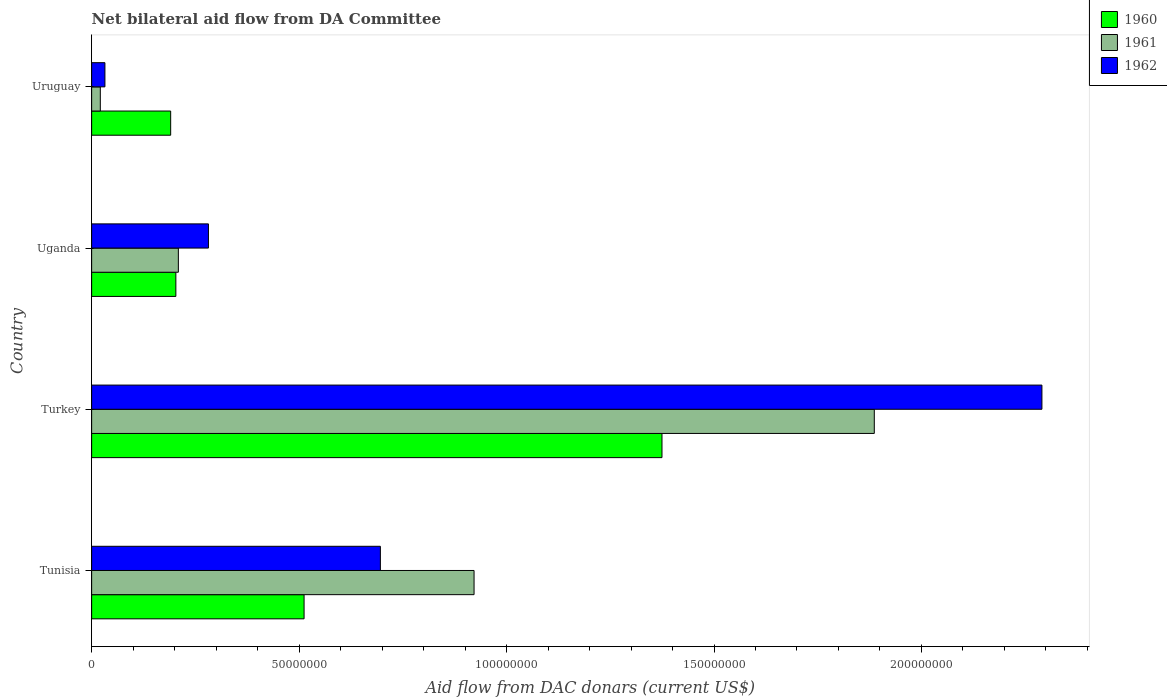How many different coloured bars are there?
Make the answer very short. 3. Are the number of bars per tick equal to the number of legend labels?
Your response must be concise. Yes. How many bars are there on the 1st tick from the top?
Keep it short and to the point. 3. How many bars are there on the 4th tick from the bottom?
Offer a terse response. 3. In how many cases, is the number of bars for a given country not equal to the number of legend labels?
Ensure brevity in your answer.  0. What is the aid flow in in 1960 in Turkey?
Keep it short and to the point. 1.37e+08. Across all countries, what is the maximum aid flow in in 1961?
Keep it short and to the point. 1.89e+08. Across all countries, what is the minimum aid flow in in 1962?
Provide a succinct answer. 3.20e+06. In which country was the aid flow in in 1962 minimum?
Provide a succinct answer. Uruguay. What is the total aid flow in in 1961 in the graph?
Provide a succinct answer. 3.04e+08. What is the difference between the aid flow in in 1960 in Tunisia and that in Uganda?
Keep it short and to the point. 3.09e+07. What is the difference between the aid flow in in 1962 in Tunisia and the aid flow in in 1960 in Uruguay?
Your answer should be very brief. 5.05e+07. What is the average aid flow in in 1962 per country?
Provide a short and direct response. 8.25e+07. What is the difference between the aid flow in in 1961 and aid flow in in 1962 in Turkey?
Make the answer very short. -4.04e+07. In how many countries, is the aid flow in in 1960 greater than 160000000 US$?
Give a very brief answer. 0. What is the ratio of the aid flow in in 1961 in Turkey to that in Uganda?
Make the answer very short. 9.03. Is the aid flow in in 1960 in Tunisia less than that in Uganda?
Your response must be concise. No. Is the difference between the aid flow in in 1961 in Uganda and Uruguay greater than the difference between the aid flow in in 1962 in Uganda and Uruguay?
Make the answer very short. No. What is the difference between the highest and the second highest aid flow in in 1960?
Offer a terse response. 8.63e+07. What is the difference between the highest and the lowest aid flow in in 1962?
Your answer should be compact. 2.26e+08. What does the 3rd bar from the top in Tunisia represents?
Provide a short and direct response. 1960. What does the 3rd bar from the bottom in Tunisia represents?
Keep it short and to the point. 1962. How many bars are there?
Offer a terse response. 12. How many countries are there in the graph?
Make the answer very short. 4. What is the difference between two consecutive major ticks on the X-axis?
Provide a short and direct response. 5.00e+07. Are the values on the major ticks of X-axis written in scientific E-notation?
Your answer should be very brief. No. Does the graph contain grids?
Provide a succinct answer. No. Where does the legend appear in the graph?
Ensure brevity in your answer.  Top right. What is the title of the graph?
Offer a terse response. Net bilateral aid flow from DA Committee. Does "2014" appear as one of the legend labels in the graph?
Give a very brief answer. No. What is the label or title of the X-axis?
Your answer should be very brief. Aid flow from DAC donars (current US$). What is the label or title of the Y-axis?
Provide a succinct answer. Country. What is the Aid flow from DAC donars (current US$) in 1960 in Tunisia?
Your answer should be compact. 5.12e+07. What is the Aid flow from DAC donars (current US$) in 1961 in Tunisia?
Keep it short and to the point. 9.22e+07. What is the Aid flow from DAC donars (current US$) in 1962 in Tunisia?
Your answer should be compact. 6.96e+07. What is the Aid flow from DAC donars (current US$) of 1960 in Turkey?
Give a very brief answer. 1.37e+08. What is the Aid flow from DAC donars (current US$) of 1961 in Turkey?
Keep it short and to the point. 1.89e+08. What is the Aid flow from DAC donars (current US$) of 1962 in Turkey?
Keep it short and to the point. 2.29e+08. What is the Aid flow from DAC donars (current US$) of 1960 in Uganda?
Your answer should be very brief. 2.03e+07. What is the Aid flow from DAC donars (current US$) in 1961 in Uganda?
Give a very brief answer. 2.09e+07. What is the Aid flow from DAC donars (current US$) of 1962 in Uganda?
Give a very brief answer. 2.82e+07. What is the Aid flow from DAC donars (current US$) in 1960 in Uruguay?
Offer a very short reply. 1.90e+07. What is the Aid flow from DAC donars (current US$) of 1961 in Uruguay?
Ensure brevity in your answer.  2.09e+06. What is the Aid flow from DAC donars (current US$) of 1962 in Uruguay?
Offer a very short reply. 3.20e+06. Across all countries, what is the maximum Aid flow from DAC donars (current US$) in 1960?
Ensure brevity in your answer.  1.37e+08. Across all countries, what is the maximum Aid flow from DAC donars (current US$) in 1961?
Your response must be concise. 1.89e+08. Across all countries, what is the maximum Aid flow from DAC donars (current US$) in 1962?
Offer a terse response. 2.29e+08. Across all countries, what is the minimum Aid flow from DAC donars (current US$) in 1960?
Your answer should be very brief. 1.90e+07. Across all countries, what is the minimum Aid flow from DAC donars (current US$) in 1961?
Keep it short and to the point. 2.09e+06. Across all countries, what is the minimum Aid flow from DAC donars (current US$) of 1962?
Your answer should be very brief. 3.20e+06. What is the total Aid flow from DAC donars (current US$) of 1960 in the graph?
Make the answer very short. 2.28e+08. What is the total Aid flow from DAC donars (current US$) in 1961 in the graph?
Keep it short and to the point. 3.04e+08. What is the total Aid flow from DAC donars (current US$) in 1962 in the graph?
Your response must be concise. 3.30e+08. What is the difference between the Aid flow from DAC donars (current US$) of 1960 in Tunisia and that in Turkey?
Ensure brevity in your answer.  -8.63e+07. What is the difference between the Aid flow from DAC donars (current US$) in 1961 in Tunisia and that in Turkey?
Offer a terse response. -9.65e+07. What is the difference between the Aid flow from DAC donars (current US$) of 1962 in Tunisia and that in Turkey?
Provide a short and direct response. -1.59e+08. What is the difference between the Aid flow from DAC donars (current US$) of 1960 in Tunisia and that in Uganda?
Provide a succinct answer. 3.09e+07. What is the difference between the Aid flow from DAC donars (current US$) in 1961 in Tunisia and that in Uganda?
Your answer should be compact. 7.13e+07. What is the difference between the Aid flow from DAC donars (current US$) of 1962 in Tunisia and that in Uganda?
Offer a terse response. 4.14e+07. What is the difference between the Aid flow from DAC donars (current US$) in 1960 in Tunisia and that in Uruguay?
Give a very brief answer. 3.22e+07. What is the difference between the Aid flow from DAC donars (current US$) of 1961 in Tunisia and that in Uruguay?
Make the answer very short. 9.01e+07. What is the difference between the Aid flow from DAC donars (current US$) of 1962 in Tunisia and that in Uruguay?
Offer a terse response. 6.64e+07. What is the difference between the Aid flow from DAC donars (current US$) in 1960 in Turkey and that in Uganda?
Offer a very short reply. 1.17e+08. What is the difference between the Aid flow from DAC donars (current US$) in 1961 in Turkey and that in Uganda?
Offer a terse response. 1.68e+08. What is the difference between the Aid flow from DAC donars (current US$) of 1962 in Turkey and that in Uganda?
Give a very brief answer. 2.01e+08. What is the difference between the Aid flow from DAC donars (current US$) in 1960 in Turkey and that in Uruguay?
Make the answer very short. 1.18e+08. What is the difference between the Aid flow from DAC donars (current US$) of 1961 in Turkey and that in Uruguay?
Ensure brevity in your answer.  1.87e+08. What is the difference between the Aid flow from DAC donars (current US$) of 1962 in Turkey and that in Uruguay?
Offer a very short reply. 2.26e+08. What is the difference between the Aid flow from DAC donars (current US$) in 1960 in Uganda and that in Uruguay?
Offer a very short reply. 1.25e+06. What is the difference between the Aid flow from DAC donars (current US$) of 1961 in Uganda and that in Uruguay?
Your response must be concise. 1.88e+07. What is the difference between the Aid flow from DAC donars (current US$) in 1962 in Uganda and that in Uruguay?
Provide a short and direct response. 2.50e+07. What is the difference between the Aid flow from DAC donars (current US$) in 1960 in Tunisia and the Aid flow from DAC donars (current US$) in 1961 in Turkey?
Ensure brevity in your answer.  -1.37e+08. What is the difference between the Aid flow from DAC donars (current US$) in 1960 in Tunisia and the Aid flow from DAC donars (current US$) in 1962 in Turkey?
Ensure brevity in your answer.  -1.78e+08. What is the difference between the Aid flow from DAC donars (current US$) of 1961 in Tunisia and the Aid flow from DAC donars (current US$) of 1962 in Turkey?
Ensure brevity in your answer.  -1.37e+08. What is the difference between the Aid flow from DAC donars (current US$) of 1960 in Tunisia and the Aid flow from DAC donars (current US$) of 1961 in Uganda?
Keep it short and to the point. 3.03e+07. What is the difference between the Aid flow from DAC donars (current US$) in 1960 in Tunisia and the Aid flow from DAC donars (current US$) in 1962 in Uganda?
Your answer should be compact. 2.30e+07. What is the difference between the Aid flow from DAC donars (current US$) in 1961 in Tunisia and the Aid flow from DAC donars (current US$) in 1962 in Uganda?
Your answer should be compact. 6.40e+07. What is the difference between the Aid flow from DAC donars (current US$) of 1960 in Tunisia and the Aid flow from DAC donars (current US$) of 1961 in Uruguay?
Offer a very short reply. 4.91e+07. What is the difference between the Aid flow from DAC donars (current US$) in 1960 in Tunisia and the Aid flow from DAC donars (current US$) in 1962 in Uruguay?
Make the answer very short. 4.80e+07. What is the difference between the Aid flow from DAC donars (current US$) of 1961 in Tunisia and the Aid flow from DAC donars (current US$) of 1962 in Uruguay?
Your answer should be very brief. 8.90e+07. What is the difference between the Aid flow from DAC donars (current US$) in 1960 in Turkey and the Aid flow from DAC donars (current US$) in 1961 in Uganda?
Your response must be concise. 1.17e+08. What is the difference between the Aid flow from DAC donars (current US$) of 1960 in Turkey and the Aid flow from DAC donars (current US$) of 1962 in Uganda?
Ensure brevity in your answer.  1.09e+08. What is the difference between the Aid flow from DAC donars (current US$) in 1961 in Turkey and the Aid flow from DAC donars (current US$) in 1962 in Uganda?
Offer a terse response. 1.60e+08. What is the difference between the Aid flow from DAC donars (current US$) in 1960 in Turkey and the Aid flow from DAC donars (current US$) in 1961 in Uruguay?
Provide a short and direct response. 1.35e+08. What is the difference between the Aid flow from DAC donars (current US$) in 1960 in Turkey and the Aid flow from DAC donars (current US$) in 1962 in Uruguay?
Offer a terse response. 1.34e+08. What is the difference between the Aid flow from DAC donars (current US$) in 1961 in Turkey and the Aid flow from DAC donars (current US$) in 1962 in Uruguay?
Ensure brevity in your answer.  1.85e+08. What is the difference between the Aid flow from DAC donars (current US$) of 1960 in Uganda and the Aid flow from DAC donars (current US$) of 1961 in Uruguay?
Offer a very short reply. 1.82e+07. What is the difference between the Aid flow from DAC donars (current US$) of 1960 in Uganda and the Aid flow from DAC donars (current US$) of 1962 in Uruguay?
Offer a very short reply. 1.71e+07. What is the difference between the Aid flow from DAC donars (current US$) of 1961 in Uganda and the Aid flow from DAC donars (current US$) of 1962 in Uruguay?
Give a very brief answer. 1.77e+07. What is the average Aid flow from DAC donars (current US$) in 1960 per country?
Ensure brevity in your answer.  5.70e+07. What is the average Aid flow from DAC donars (current US$) of 1961 per country?
Give a very brief answer. 7.59e+07. What is the average Aid flow from DAC donars (current US$) in 1962 per country?
Offer a terse response. 8.25e+07. What is the difference between the Aid flow from DAC donars (current US$) in 1960 and Aid flow from DAC donars (current US$) in 1961 in Tunisia?
Ensure brevity in your answer.  -4.10e+07. What is the difference between the Aid flow from DAC donars (current US$) in 1960 and Aid flow from DAC donars (current US$) in 1962 in Tunisia?
Make the answer very short. -1.84e+07. What is the difference between the Aid flow from DAC donars (current US$) in 1961 and Aid flow from DAC donars (current US$) in 1962 in Tunisia?
Your answer should be compact. 2.26e+07. What is the difference between the Aid flow from DAC donars (current US$) of 1960 and Aid flow from DAC donars (current US$) of 1961 in Turkey?
Keep it short and to the point. -5.12e+07. What is the difference between the Aid flow from DAC donars (current US$) of 1960 and Aid flow from DAC donars (current US$) of 1962 in Turkey?
Provide a succinct answer. -9.16e+07. What is the difference between the Aid flow from DAC donars (current US$) in 1961 and Aid flow from DAC donars (current US$) in 1962 in Turkey?
Ensure brevity in your answer.  -4.04e+07. What is the difference between the Aid flow from DAC donars (current US$) in 1960 and Aid flow from DAC donars (current US$) in 1961 in Uganda?
Offer a very short reply. -6.00e+05. What is the difference between the Aid flow from DAC donars (current US$) in 1960 and Aid flow from DAC donars (current US$) in 1962 in Uganda?
Give a very brief answer. -7.85e+06. What is the difference between the Aid flow from DAC donars (current US$) of 1961 and Aid flow from DAC donars (current US$) of 1962 in Uganda?
Give a very brief answer. -7.25e+06. What is the difference between the Aid flow from DAC donars (current US$) in 1960 and Aid flow from DAC donars (current US$) in 1961 in Uruguay?
Your response must be concise. 1.70e+07. What is the difference between the Aid flow from DAC donars (current US$) of 1960 and Aid flow from DAC donars (current US$) of 1962 in Uruguay?
Make the answer very short. 1.58e+07. What is the difference between the Aid flow from DAC donars (current US$) in 1961 and Aid flow from DAC donars (current US$) in 1962 in Uruguay?
Provide a short and direct response. -1.11e+06. What is the ratio of the Aid flow from DAC donars (current US$) in 1960 in Tunisia to that in Turkey?
Offer a terse response. 0.37. What is the ratio of the Aid flow from DAC donars (current US$) of 1961 in Tunisia to that in Turkey?
Offer a terse response. 0.49. What is the ratio of the Aid flow from DAC donars (current US$) in 1962 in Tunisia to that in Turkey?
Offer a terse response. 0.3. What is the ratio of the Aid flow from DAC donars (current US$) in 1960 in Tunisia to that in Uganda?
Make the answer very short. 2.52. What is the ratio of the Aid flow from DAC donars (current US$) in 1961 in Tunisia to that in Uganda?
Provide a succinct answer. 4.41. What is the ratio of the Aid flow from DAC donars (current US$) of 1962 in Tunisia to that in Uganda?
Ensure brevity in your answer.  2.47. What is the ratio of the Aid flow from DAC donars (current US$) in 1960 in Tunisia to that in Uruguay?
Give a very brief answer. 2.69. What is the ratio of the Aid flow from DAC donars (current US$) in 1961 in Tunisia to that in Uruguay?
Provide a short and direct response. 44.1. What is the ratio of the Aid flow from DAC donars (current US$) of 1962 in Tunisia to that in Uruguay?
Give a very brief answer. 21.75. What is the ratio of the Aid flow from DAC donars (current US$) in 1960 in Turkey to that in Uganda?
Make the answer very short. 6.77. What is the ratio of the Aid flow from DAC donars (current US$) of 1961 in Turkey to that in Uganda?
Your response must be concise. 9.03. What is the ratio of the Aid flow from DAC donars (current US$) in 1962 in Turkey to that in Uganda?
Ensure brevity in your answer.  8.14. What is the ratio of the Aid flow from DAC donars (current US$) in 1960 in Turkey to that in Uruguay?
Keep it short and to the point. 7.22. What is the ratio of the Aid flow from DAC donars (current US$) in 1961 in Turkey to that in Uruguay?
Offer a terse response. 90.25. What is the ratio of the Aid flow from DAC donars (current US$) of 1962 in Turkey to that in Uruguay?
Ensure brevity in your answer.  71.57. What is the ratio of the Aid flow from DAC donars (current US$) of 1960 in Uganda to that in Uruguay?
Your response must be concise. 1.07. What is the ratio of the Aid flow from DAC donars (current US$) in 1961 in Uganda to that in Uruguay?
Your response must be concise. 10. What is the ratio of the Aid flow from DAC donars (current US$) in 1962 in Uganda to that in Uruguay?
Give a very brief answer. 8.8. What is the difference between the highest and the second highest Aid flow from DAC donars (current US$) in 1960?
Your answer should be very brief. 8.63e+07. What is the difference between the highest and the second highest Aid flow from DAC donars (current US$) in 1961?
Ensure brevity in your answer.  9.65e+07. What is the difference between the highest and the second highest Aid flow from DAC donars (current US$) in 1962?
Make the answer very short. 1.59e+08. What is the difference between the highest and the lowest Aid flow from DAC donars (current US$) in 1960?
Make the answer very short. 1.18e+08. What is the difference between the highest and the lowest Aid flow from DAC donars (current US$) in 1961?
Make the answer very short. 1.87e+08. What is the difference between the highest and the lowest Aid flow from DAC donars (current US$) of 1962?
Ensure brevity in your answer.  2.26e+08. 